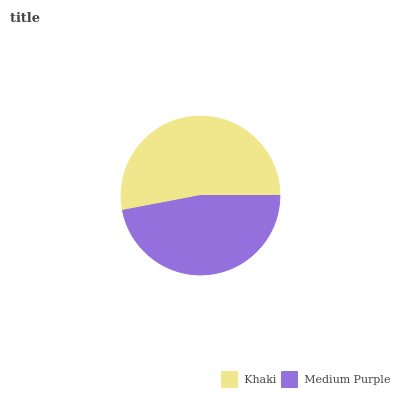Is Medium Purple the minimum?
Answer yes or no. Yes. Is Khaki the maximum?
Answer yes or no. Yes. Is Medium Purple the maximum?
Answer yes or no. No. Is Khaki greater than Medium Purple?
Answer yes or no. Yes. Is Medium Purple less than Khaki?
Answer yes or no. Yes. Is Medium Purple greater than Khaki?
Answer yes or no. No. Is Khaki less than Medium Purple?
Answer yes or no. No. Is Khaki the high median?
Answer yes or no. Yes. Is Medium Purple the low median?
Answer yes or no. Yes. Is Medium Purple the high median?
Answer yes or no. No. Is Khaki the low median?
Answer yes or no. No. 